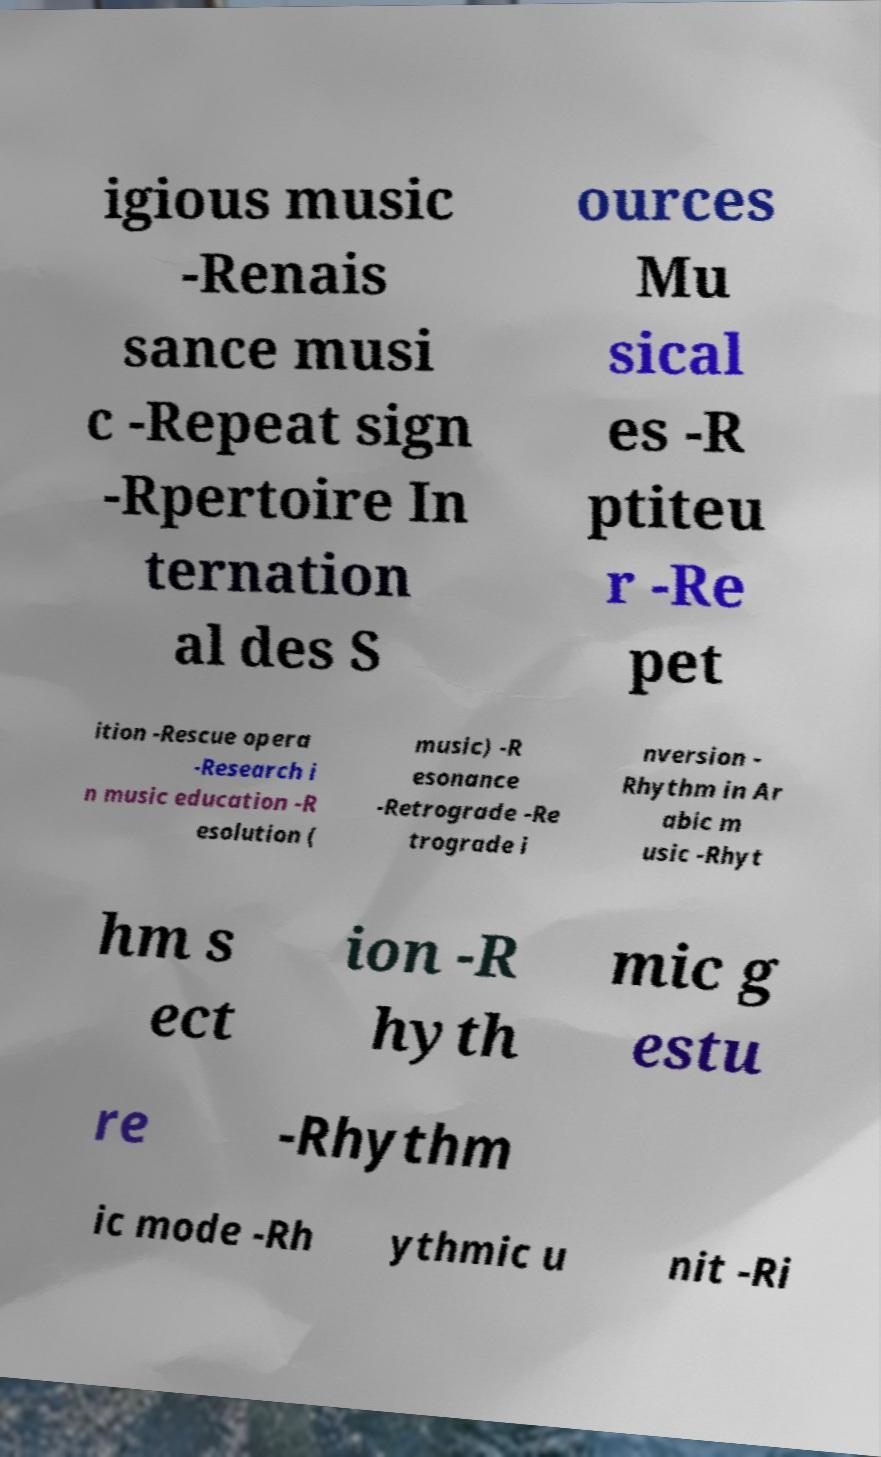I need the written content from this picture converted into text. Can you do that? igious music -Renais sance musi c -Repeat sign -Rpertoire In ternation al des S ources Mu sical es -R ptiteu r -Re pet ition -Rescue opera -Research i n music education -R esolution ( music) -R esonance -Retrograde -Re trograde i nversion - Rhythm in Ar abic m usic -Rhyt hm s ect ion -R hyth mic g estu re -Rhythm ic mode -Rh ythmic u nit -Ri 